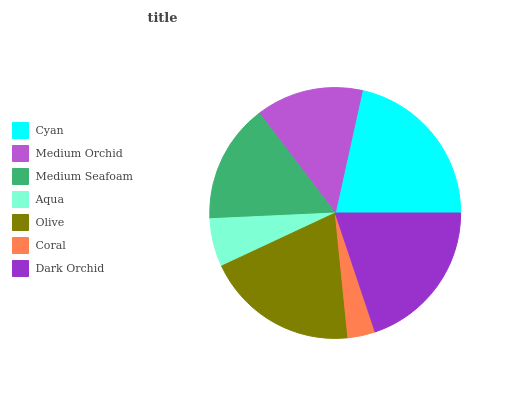Is Coral the minimum?
Answer yes or no. Yes. Is Cyan the maximum?
Answer yes or no. Yes. Is Medium Orchid the minimum?
Answer yes or no. No. Is Medium Orchid the maximum?
Answer yes or no. No. Is Cyan greater than Medium Orchid?
Answer yes or no. Yes. Is Medium Orchid less than Cyan?
Answer yes or no. Yes. Is Medium Orchid greater than Cyan?
Answer yes or no. No. Is Cyan less than Medium Orchid?
Answer yes or no. No. Is Medium Seafoam the high median?
Answer yes or no. Yes. Is Medium Seafoam the low median?
Answer yes or no. Yes. Is Aqua the high median?
Answer yes or no. No. Is Olive the low median?
Answer yes or no. No. 